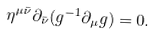<formula> <loc_0><loc_0><loc_500><loc_500>\eta ^ { \mu { \bar { \nu } } } \partial _ { \bar { \nu } } ( g ^ { - 1 } \partial _ { \mu } g ) = 0 .</formula> 